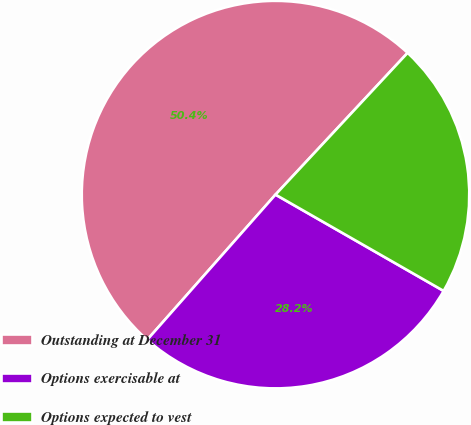Convert chart. <chart><loc_0><loc_0><loc_500><loc_500><pie_chart><fcel>Outstanding at December 31<fcel>Options exercisable at<fcel>Options expected to vest<nl><fcel>50.42%<fcel>28.24%<fcel>21.34%<nl></chart> 